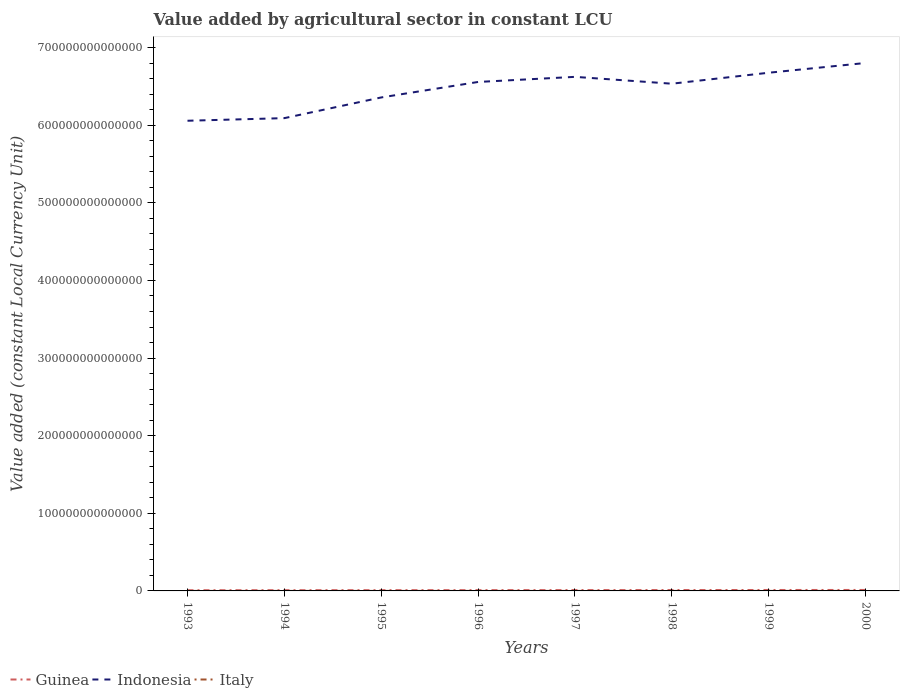Does the line corresponding to Indonesia intersect with the line corresponding to Guinea?
Your response must be concise. No. Is the number of lines equal to the number of legend labels?
Your response must be concise. Yes. Across all years, what is the maximum value added by agricultural sector in Indonesia?
Your answer should be very brief. 6.06e+14. What is the total value added by agricultural sector in Indonesia in the graph?
Provide a short and direct response. -2.65e+13. What is the difference between the highest and the second highest value added by agricultural sector in Guinea?
Your answer should be very brief. 3.37e+11. Is the value added by agricultural sector in Guinea strictly greater than the value added by agricultural sector in Italy over the years?
Make the answer very short. No. What is the difference between two consecutive major ticks on the Y-axis?
Make the answer very short. 1.00e+14. Are the values on the major ticks of Y-axis written in scientific E-notation?
Offer a very short reply. No. Does the graph contain any zero values?
Make the answer very short. No. Does the graph contain grids?
Keep it short and to the point. No. How many legend labels are there?
Provide a short and direct response. 3. How are the legend labels stacked?
Your response must be concise. Horizontal. What is the title of the graph?
Provide a succinct answer. Value added by agricultural sector in constant LCU. Does "Caribbean small states" appear as one of the legend labels in the graph?
Offer a very short reply. No. What is the label or title of the X-axis?
Offer a very short reply. Years. What is the label or title of the Y-axis?
Provide a short and direct response. Value added (constant Local Currency Unit). What is the Value added (constant Local Currency Unit) in Guinea in 1993?
Ensure brevity in your answer.  9.07e+11. What is the Value added (constant Local Currency Unit) in Indonesia in 1993?
Offer a terse response. 6.06e+14. What is the Value added (constant Local Currency Unit) of Italy in 1993?
Provide a short and direct response. 2.63e+1. What is the Value added (constant Local Currency Unit) in Guinea in 1994?
Provide a succinct answer. 9.46e+11. What is the Value added (constant Local Currency Unit) in Indonesia in 1994?
Provide a short and direct response. 6.09e+14. What is the Value added (constant Local Currency Unit) in Italy in 1994?
Your answer should be compact. 2.67e+1. What is the Value added (constant Local Currency Unit) of Guinea in 1995?
Offer a very short reply. 9.75e+11. What is the Value added (constant Local Currency Unit) of Indonesia in 1995?
Your answer should be compact. 6.36e+14. What is the Value added (constant Local Currency Unit) of Italy in 1995?
Make the answer very short. 2.71e+1. What is the Value added (constant Local Currency Unit) in Guinea in 1996?
Keep it short and to the point. 1.02e+12. What is the Value added (constant Local Currency Unit) of Indonesia in 1996?
Your response must be concise. 6.56e+14. What is the Value added (constant Local Currency Unit) in Italy in 1996?
Offer a very short reply. 2.74e+1. What is the Value added (constant Local Currency Unit) of Guinea in 1997?
Offer a terse response. 1.08e+12. What is the Value added (constant Local Currency Unit) of Indonesia in 1997?
Provide a succinct answer. 6.62e+14. What is the Value added (constant Local Currency Unit) in Italy in 1997?
Give a very brief answer. 2.80e+1. What is the Value added (constant Local Currency Unit) of Guinea in 1998?
Keep it short and to the point. 1.13e+12. What is the Value added (constant Local Currency Unit) in Indonesia in 1998?
Keep it short and to the point. 6.54e+14. What is the Value added (constant Local Currency Unit) of Italy in 1998?
Your answer should be compact. 2.88e+1. What is the Value added (constant Local Currency Unit) of Guinea in 1999?
Your answer should be compact. 1.21e+12. What is the Value added (constant Local Currency Unit) in Indonesia in 1999?
Offer a terse response. 6.68e+14. What is the Value added (constant Local Currency Unit) in Italy in 1999?
Give a very brief answer. 3.04e+1. What is the Value added (constant Local Currency Unit) of Guinea in 2000?
Provide a succinct answer. 1.24e+12. What is the Value added (constant Local Currency Unit) in Indonesia in 2000?
Your answer should be very brief. 6.80e+14. What is the Value added (constant Local Currency Unit) of Italy in 2000?
Make the answer very short. 3.00e+1. Across all years, what is the maximum Value added (constant Local Currency Unit) in Guinea?
Keep it short and to the point. 1.24e+12. Across all years, what is the maximum Value added (constant Local Currency Unit) in Indonesia?
Make the answer very short. 6.80e+14. Across all years, what is the maximum Value added (constant Local Currency Unit) of Italy?
Give a very brief answer. 3.04e+1. Across all years, what is the minimum Value added (constant Local Currency Unit) of Guinea?
Your answer should be very brief. 9.07e+11. Across all years, what is the minimum Value added (constant Local Currency Unit) in Indonesia?
Offer a terse response. 6.06e+14. Across all years, what is the minimum Value added (constant Local Currency Unit) of Italy?
Provide a succinct answer. 2.63e+1. What is the total Value added (constant Local Currency Unit) of Guinea in the graph?
Make the answer very short. 8.51e+12. What is the total Value added (constant Local Currency Unit) in Indonesia in the graph?
Provide a short and direct response. 5.17e+15. What is the total Value added (constant Local Currency Unit) of Italy in the graph?
Offer a very short reply. 2.25e+11. What is the difference between the Value added (constant Local Currency Unit) of Guinea in 1993 and that in 1994?
Your answer should be very brief. -3.95e+1. What is the difference between the Value added (constant Local Currency Unit) in Indonesia in 1993 and that in 1994?
Make the answer very short. -3.37e+12. What is the difference between the Value added (constant Local Currency Unit) in Italy in 1993 and that in 1994?
Offer a terse response. -3.83e+08. What is the difference between the Value added (constant Local Currency Unit) of Guinea in 1993 and that in 1995?
Ensure brevity in your answer.  -6.84e+1. What is the difference between the Value added (constant Local Currency Unit) of Indonesia in 1993 and that in 1995?
Provide a succinct answer. -3.00e+13. What is the difference between the Value added (constant Local Currency Unit) of Italy in 1993 and that in 1995?
Give a very brief answer. -8.41e+08. What is the difference between the Value added (constant Local Currency Unit) in Guinea in 1993 and that in 1996?
Ensure brevity in your answer.  -1.11e+11. What is the difference between the Value added (constant Local Currency Unit) in Indonesia in 1993 and that in 1996?
Ensure brevity in your answer.  -5.00e+13. What is the difference between the Value added (constant Local Currency Unit) of Italy in 1993 and that in 1996?
Your answer should be compact. -1.15e+09. What is the difference between the Value added (constant Local Currency Unit) in Guinea in 1993 and that in 1997?
Provide a short and direct response. -1.76e+11. What is the difference between the Value added (constant Local Currency Unit) in Indonesia in 1993 and that in 1997?
Provide a short and direct response. -5.66e+13. What is the difference between the Value added (constant Local Currency Unit) of Italy in 1993 and that in 1997?
Provide a short and direct response. -1.75e+09. What is the difference between the Value added (constant Local Currency Unit) in Guinea in 1993 and that in 1998?
Your response must be concise. -2.27e+11. What is the difference between the Value added (constant Local Currency Unit) in Indonesia in 1993 and that in 1998?
Offer a terse response. -4.77e+13. What is the difference between the Value added (constant Local Currency Unit) in Italy in 1993 and that in 1998?
Your answer should be very brief. -2.50e+09. What is the difference between the Value added (constant Local Currency Unit) in Guinea in 1993 and that in 1999?
Make the answer very short. -3.01e+11. What is the difference between the Value added (constant Local Currency Unit) of Indonesia in 1993 and that in 1999?
Your response must be concise. -6.19e+13. What is the difference between the Value added (constant Local Currency Unit) of Italy in 1993 and that in 1999?
Provide a succinct answer. -4.15e+09. What is the difference between the Value added (constant Local Currency Unit) of Guinea in 1993 and that in 2000?
Your response must be concise. -3.37e+11. What is the difference between the Value added (constant Local Currency Unit) of Indonesia in 1993 and that in 2000?
Offer a very short reply. -7.44e+13. What is the difference between the Value added (constant Local Currency Unit) of Italy in 1993 and that in 2000?
Your answer should be compact. -3.75e+09. What is the difference between the Value added (constant Local Currency Unit) in Guinea in 1994 and that in 1995?
Provide a succinct answer. -2.89e+1. What is the difference between the Value added (constant Local Currency Unit) of Indonesia in 1994 and that in 1995?
Keep it short and to the point. -2.67e+13. What is the difference between the Value added (constant Local Currency Unit) in Italy in 1994 and that in 1995?
Make the answer very short. -4.58e+08. What is the difference between the Value added (constant Local Currency Unit) of Guinea in 1994 and that in 1996?
Your answer should be very brief. -7.10e+1. What is the difference between the Value added (constant Local Currency Unit) in Indonesia in 1994 and that in 1996?
Provide a short and direct response. -4.66e+13. What is the difference between the Value added (constant Local Currency Unit) of Italy in 1994 and that in 1996?
Offer a very short reply. -7.68e+08. What is the difference between the Value added (constant Local Currency Unit) in Guinea in 1994 and that in 1997?
Offer a very short reply. -1.37e+11. What is the difference between the Value added (constant Local Currency Unit) of Indonesia in 1994 and that in 1997?
Make the answer very short. -5.32e+13. What is the difference between the Value added (constant Local Currency Unit) in Italy in 1994 and that in 1997?
Offer a terse response. -1.37e+09. What is the difference between the Value added (constant Local Currency Unit) of Guinea in 1994 and that in 1998?
Provide a short and direct response. -1.87e+11. What is the difference between the Value added (constant Local Currency Unit) of Indonesia in 1994 and that in 1998?
Provide a short and direct response. -4.44e+13. What is the difference between the Value added (constant Local Currency Unit) of Italy in 1994 and that in 1998?
Provide a succinct answer. -2.11e+09. What is the difference between the Value added (constant Local Currency Unit) in Guinea in 1994 and that in 1999?
Your response must be concise. -2.62e+11. What is the difference between the Value added (constant Local Currency Unit) of Indonesia in 1994 and that in 1999?
Ensure brevity in your answer.  -5.85e+13. What is the difference between the Value added (constant Local Currency Unit) in Italy in 1994 and that in 1999?
Keep it short and to the point. -3.76e+09. What is the difference between the Value added (constant Local Currency Unit) of Guinea in 1994 and that in 2000?
Provide a succinct answer. -2.98e+11. What is the difference between the Value added (constant Local Currency Unit) of Indonesia in 1994 and that in 2000?
Keep it short and to the point. -7.11e+13. What is the difference between the Value added (constant Local Currency Unit) in Italy in 1994 and that in 2000?
Give a very brief answer. -3.36e+09. What is the difference between the Value added (constant Local Currency Unit) of Guinea in 1995 and that in 1996?
Keep it short and to the point. -4.21e+1. What is the difference between the Value added (constant Local Currency Unit) in Indonesia in 1995 and that in 1996?
Offer a terse response. -2.00e+13. What is the difference between the Value added (constant Local Currency Unit) of Italy in 1995 and that in 1996?
Offer a very short reply. -3.10e+08. What is the difference between the Value added (constant Local Currency Unit) of Guinea in 1995 and that in 1997?
Your answer should be very brief. -1.08e+11. What is the difference between the Value added (constant Local Currency Unit) of Indonesia in 1995 and that in 1997?
Ensure brevity in your answer.  -2.65e+13. What is the difference between the Value added (constant Local Currency Unit) in Italy in 1995 and that in 1997?
Ensure brevity in your answer.  -9.11e+08. What is the difference between the Value added (constant Local Currency Unit) in Guinea in 1995 and that in 1998?
Your answer should be very brief. -1.58e+11. What is the difference between the Value added (constant Local Currency Unit) of Indonesia in 1995 and that in 1998?
Provide a succinct answer. -1.77e+13. What is the difference between the Value added (constant Local Currency Unit) of Italy in 1995 and that in 1998?
Your response must be concise. -1.66e+09. What is the difference between the Value added (constant Local Currency Unit) in Guinea in 1995 and that in 1999?
Give a very brief answer. -2.33e+11. What is the difference between the Value added (constant Local Currency Unit) in Indonesia in 1995 and that in 1999?
Provide a short and direct response. -3.19e+13. What is the difference between the Value added (constant Local Currency Unit) of Italy in 1995 and that in 1999?
Provide a succinct answer. -3.31e+09. What is the difference between the Value added (constant Local Currency Unit) in Guinea in 1995 and that in 2000?
Your answer should be compact. -2.69e+11. What is the difference between the Value added (constant Local Currency Unit) in Indonesia in 1995 and that in 2000?
Your answer should be very brief. -4.44e+13. What is the difference between the Value added (constant Local Currency Unit) of Italy in 1995 and that in 2000?
Offer a terse response. -2.91e+09. What is the difference between the Value added (constant Local Currency Unit) of Guinea in 1996 and that in 1997?
Offer a terse response. -6.59e+1. What is the difference between the Value added (constant Local Currency Unit) in Indonesia in 1996 and that in 1997?
Give a very brief answer. -6.58e+12. What is the difference between the Value added (constant Local Currency Unit) of Italy in 1996 and that in 1997?
Offer a terse response. -6.01e+08. What is the difference between the Value added (constant Local Currency Unit) in Guinea in 1996 and that in 1998?
Give a very brief answer. -1.16e+11. What is the difference between the Value added (constant Local Currency Unit) in Indonesia in 1996 and that in 1998?
Keep it short and to the point. 2.24e+12. What is the difference between the Value added (constant Local Currency Unit) of Italy in 1996 and that in 1998?
Provide a succinct answer. -1.35e+09. What is the difference between the Value added (constant Local Currency Unit) in Guinea in 1996 and that in 1999?
Offer a very short reply. -1.91e+11. What is the difference between the Value added (constant Local Currency Unit) in Indonesia in 1996 and that in 1999?
Give a very brief answer. -1.19e+13. What is the difference between the Value added (constant Local Currency Unit) of Italy in 1996 and that in 1999?
Offer a terse response. -3.00e+09. What is the difference between the Value added (constant Local Currency Unit) in Guinea in 1996 and that in 2000?
Provide a short and direct response. -2.27e+11. What is the difference between the Value added (constant Local Currency Unit) in Indonesia in 1996 and that in 2000?
Provide a short and direct response. -2.45e+13. What is the difference between the Value added (constant Local Currency Unit) of Italy in 1996 and that in 2000?
Offer a terse response. -2.60e+09. What is the difference between the Value added (constant Local Currency Unit) in Guinea in 1997 and that in 1998?
Ensure brevity in your answer.  -5.02e+1. What is the difference between the Value added (constant Local Currency Unit) of Indonesia in 1997 and that in 1998?
Make the answer very short. 8.82e+12. What is the difference between the Value added (constant Local Currency Unit) in Italy in 1997 and that in 1998?
Offer a very short reply. -7.46e+08. What is the difference between the Value added (constant Local Currency Unit) in Guinea in 1997 and that in 1999?
Your response must be concise. -1.25e+11. What is the difference between the Value added (constant Local Currency Unit) of Indonesia in 1997 and that in 1999?
Your answer should be compact. -5.32e+12. What is the difference between the Value added (constant Local Currency Unit) of Italy in 1997 and that in 1999?
Your response must be concise. -2.40e+09. What is the difference between the Value added (constant Local Currency Unit) of Guinea in 1997 and that in 2000?
Provide a short and direct response. -1.61e+11. What is the difference between the Value added (constant Local Currency Unit) of Indonesia in 1997 and that in 2000?
Keep it short and to the point. -1.79e+13. What is the difference between the Value added (constant Local Currency Unit) in Italy in 1997 and that in 2000?
Provide a short and direct response. -2.00e+09. What is the difference between the Value added (constant Local Currency Unit) in Guinea in 1998 and that in 1999?
Keep it short and to the point. -7.49e+1. What is the difference between the Value added (constant Local Currency Unit) of Indonesia in 1998 and that in 1999?
Your answer should be very brief. -1.41e+13. What is the difference between the Value added (constant Local Currency Unit) in Italy in 1998 and that in 1999?
Keep it short and to the point. -1.65e+09. What is the difference between the Value added (constant Local Currency Unit) of Guinea in 1998 and that in 2000?
Provide a succinct answer. -1.10e+11. What is the difference between the Value added (constant Local Currency Unit) of Indonesia in 1998 and that in 2000?
Give a very brief answer. -2.67e+13. What is the difference between the Value added (constant Local Currency Unit) of Italy in 1998 and that in 2000?
Offer a very short reply. -1.25e+09. What is the difference between the Value added (constant Local Currency Unit) in Guinea in 1999 and that in 2000?
Your response must be concise. -3.56e+1. What is the difference between the Value added (constant Local Currency Unit) of Indonesia in 1999 and that in 2000?
Your answer should be very brief. -1.26e+13. What is the difference between the Value added (constant Local Currency Unit) in Italy in 1999 and that in 2000?
Your answer should be very brief. 4.00e+08. What is the difference between the Value added (constant Local Currency Unit) in Guinea in 1993 and the Value added (constant Local Currency Unit) in Indonesia in 1994?
Offer a terse response. -6.08e+14. What is the difference between the Value added (constant Local Currency Unit) of Guinea in 1993 and the Value added (constant Local Currency Unit) of Italy in 1994?
Provide a succinct answer. 8.80e+11. What is the difference between the Value added (constant Local Currency Unit) of Indonesia in 1993 and the Value added (constant Local Currency Unit) of Italy in 1994?
Your answer should be very brief. 6.06e+14. What is the difference between the Value added (constant Local Currency Unit) in Guinea in 1993 and the Value added (constant Local Currency Unit) in Indonesia in 1995?
Provide a succinct answer. -6.35e+14. What is the difference between the Value added (constant Local Currency Unit) of Guinea in 1993 and the Value added (constant Local Currency Unit) of Italy in 1995?
Your answer should be compact. 8.80e+11. What is the difference between the Value added (constant Local Currency Unit) in Indonesia in 1993 and the Value added (constant Local Currency Unit) in Italy in 1995?
Keep it short and to the point. 6.06e+14. What is the difference between the Value added (constant Local Currency Unit) in Guinea in 1993 and the Value added (constant Local Currency Unit) in Indonesia in 1996?
Give a very brief answer. -6.55e+14. What is the difference between the Value added (constant Local Currency Unit) in Guinea in 1993 and the Value added (constant Local Currency Unit) in Italy in 1996?
Provide a succinct answer. 8.79e+11. What is the difference between the Value added (constant Local Currency Unit) in Indonesia in 1993 and the Value added (constant Local Currency Unit) in Italy in 1996?
Your response must be concise. 6.06e+14. What is the difference between the Value added (constant Local Currency Unit) of Guinea in 1993 and the Value added (constant Local Currency Unit) of Indonesia in 1997?
Offer a terse response. -6.61e+14. What is the difference between the Value added (constant Local Currency Unit) in Guinea in 1993 and the Value added (constant Local Currency Unit) in Italy in 1997?
Your response must be concise. 8.79e+11. What is the difference between the Value added (constant Local Currency Unit) of Indonesia in 1993 and the Value added (constant Local Currency Unit) of Italy in 1997?
Keep it short and to the point. 6.06e+14. What is the difference between the Value added (constant Local Currency Unit) in Guinea in 1993 and the Value added (constant Local Currency Unit) in Indonesia in 1998?
Offer a terse response. -6.53e+14. What is the difference between the Value added (constant Local Currency Unit) of Guinea in 1993 and the Value added (constant Local Currency Unit) of Italy in 1998?
Provide a succinct answer. 8.78e+11. What is the difference between the Value added (constant Local Currency Unit) in Indonesia in 1993 and the Value added (constant Local Currency Unit) in Italy in 1998?
Your answer should be very brief. 6.06e+14. What is the difference between the Value added (constant Local Currency Unit) in Guinea in 1993 and the Value added (constant Local Currency Unit) in Indonesia in 1999?
Keep it short and to the point. -6.67e+14. What is the difference between the Value added (constant Local Currency Unit) in Guinea in 1993 and the Value added (constant Local Currency Unit) in Italy in 1999?
Your answer should be very brief. 8.76e+11. What is the difference between the Value added (constant Local Currency Unit) in Indonesia in 1993 and the Value added (constant Local Currency Unit) in Italy in 1999?
Ensure brevity in your answer.  6.06e+14. What is the difference between the Value added (constant Local Currency Unit) of Guinea in 1993 and the Value added (constant Local Currency Unit) of Indonesia in 2000?
Make the answer very short. -6.79e+14. What is the difference between the Value added (constant Local Currency Unit) in Guinea in 1993 and the Value added (constant Local Currency Unit) in Italy in 2000?
Provide a succinct answer. 8.77e+11. What is the difference between the Value added (constant Local Currency Unit) of Indonesia in 1993 and the Value added (constant Local Currency Unit) of Italy in 2000?
Ensure brevity in your answer.  6.06e+14. What is the difference between the Value added (constant Local Currency Unit) of Guinea in 1994 and the Value added (constant Local Currency Unit) of Indonesia in 1995?
Your answer should be compact. -6.35e+14. What is the difference between the Value added (constant Local Currency Unit) in Guinea in 1994 and the Value added (constant Local Currency Unit) in Italy in 1995?
Keep it short and to the point. 9.19e+11. What is the difference between the Value added (constant Local Currency Unit) in Indonesia in 1994 and the Value added (constant Local Currency Unit) in Italy in 1995?
Ensure brevity in your answer.  6.09e+14. What is the difference between the Value added (constant Local Currency Unit) of Guinea in 1994 and the Value added (constant Local Currency Unit) of Indonesia in 1996?
Make the answer very short. -6.55e+14. What is the difference between the Value added (constant Local Currency Unit) in Guinea in 1994 and the Value added (constant Local Currency Unit) in Italy in 1996?
Keep it short and to the point. 9.19e+11. What is the difference between the Value added (constant Local Currency Unit) in Indonesia in 1994 and the Value added (constant Local Currency Unit) in Italy in 1996?
Ensure brevity in your answer.  6.09e+14. What is the difference between the Value added (constant Local Currency Unit) in Guinea in 1994 and the Value added (constant Local Currency Unit) in Indonesia in 1997?
Your answer should be very brief. -6.61e+14. What is the difference between the Value added (constant Local Currency Unit) in Guinea in 1994 and the Value added (constant Local Currency Unit) in Italy in 1997?
Offer a very short reply. 9.18e+11. What is the difference between the Value added (constant Local Currency Unit) in Indonesia in 1994 and the Value added (constant Local Currency Unit) in Italy in 1997?
Your answer should be very brief. 6.09e+14. What is the difference between the Value added (constant Local Currency Unit) of Guinea in 1994 and the Value added (constant Local Currency Unit) of Indonesia in 1998?
Provide a short and direct response. -6.53e+14. What is the difference between the Value added (constant Local Currency Unit) in Guinea in 1994 and the Value added (constant Local Currency Unit) in Italy in 1998?
Your answer should be compact. 9.18e+11. What is the difference between the Value added (constant Local Currency Unit) in Indonesia in 1994 and the Value added (constant Local Currency Unit) in Italy in 1998?
Ensure brevity in your answer.  6.09e+14. What is the difference between the Value added (constant Local Currency Unit) in Guinea in 1994 and the Value added (constant Local Currency Unit) in Indonesia in 1999?
Your answer should be compact. -6.67e+14. What is the difference between the Value added (constant Local Currency Unit) in Guinea in 1994 and the Value added (constant Local Currency Unit) in Italy in 1999?
Your answer should be very brief. 9.16e+11. What is the difference between the Value added (constant Local Currency Unit) of Indonesia in 1994 and the Value added (constant Local Currency Unit) of Italy in 1999?
Give a very brief answer. 6.09e+14. What is the difference between the Value added (constant Local Currency Unit) of Guinea in 1994 and the Value added (constant Local Currency Unit) of Indonesia in 2000?
Keep it short and to the point. -6.79e+14. What is the difference between the Value added (constant Local Currency Unit) of Guinea in 1994 and the Value added (constant Local Currency Unit) of Italy in 2000?
Provide a short and direct response. 9.16e+11. What is the difference between the Value added (constant Local Currency Unit) in Indonesia in 1994 and the Value added (constant Local Currency Unit) in Italy in 2000?
Your response must be concise. 6.09e+14. What is the difference between the Value added (constant Local Currency Unit) of Guinea in 1995 and the Value added (constant Local Currency Unit) of Indonesia in 1996?
Offer a terse response. -6.55e+14. What is the difference between the Value added (constant Local Currency Unit) in Guinea in 1995 and the Value added (constant Local Currency Unit) in Italy in 1996?
Keep it short and to the point. 9.48e+11. What is the difference between the Value added (constant Local Currency Unit) in Indonesia in 1995 and the Value added (constant Local Currency Unit) in Italy in 1996?
Provide a succinct answer. 6.36e+14. What is the difference between the Value added (constant Local Currency Unit) in Guinea in 1995 and the Value added (constant Local Currency Unit) in Indonesia in 1997?
Your answer should be very brief. -6.61e+14. What is the difference between the Value added (constant Local Currency Unit) of Guinea in 1995 and the Value added (constant Local Currency Unit) of Italy in 1997?
Your answer should be very brief. 9.47e+11. What is the difference between the Value added (constant Local Currency Unit) of Indonesia in 1995 and the Value added (constant Local Currency Unit) of Italy in 1997?
Keep it short and to the point. 6.36e+14. What is the difference between the Value added (constant Local Currency Unit) in Guinea in 1995 and the Value added (constant Local Currency Unit) in Indonesia in 1998?
Offer a terse response. -6.53e+14. What is the difference between the Value added (constant Local Currency Unit) in Guinea in 1995 and the Value added (constant Local Currency Unit) in Italy in 1998?
Keep it short and to the point. 9.47e+11. What is the difference between the Value added (constant Local Currency Unit) in Indonesia in 1995 and the Value added (constant Local Currency Unit) in Italy in 1998?
Provide a short and direct response. 6.36e+14. What is the difference between the Value added (constant Local Currency Unit) in Guinea in 1995 and the Value added (constant Local Currency Unit) in Indonesia in 1999?
Provide a short and direct response. -6.67e+14. What is the difference between the Value added (constant Local Currency Unit) of Guinea in 1995 and the Value added (constant Local Currency Unit) of Italy in 1999?
Keep it short and to the point. 9.45e+11. What is the difference between the Value added (constant Local Currency Unit) in Indonesia in 1995 and the Value added (constant Local Currency Unit) in Italy in 1999?
Your answer should be compact. 6.36e+14. What is the difference between the Value added (constant Local Currency Unit) in Guinea in 1995 and the Value added (constant Local Currency Unit) in Indonesia in 2000?
Your answer should be compact. -6.79e+14. What is the difference between the Value added (constant Local Currency Unit) of Guinea in 1995 and the Value added (constant Local Currency Unit) of Italy in 2000?
Offer a terse response. 9.45e+11. What is the difference between the Value added (constant Local Currency Unit) of Indonesia in 1995 and the Value added (constant Local Currency Unit) of Italy in 2000?
Ensure brevity in your answer.  6.36e+14. What is the difference between the Value added (constant Local Currency Unit) of Guinea in 1996 and the Value added (constant Local Currency Unit) of Indonesia in 1997?
Offer a terse response. -6.61e+14. What is the difference between the Value added (constant Local Currency Unit) in Guinea in 1996 and the Value added (constant Local Currency Unit) in Italy in 1997?
Your response must be concise. 9.89e+11. What is the difference between the Value added (constant Local Currency Unit) of Indonesia in 1996 and the Value added (constant Local Currency Unit) of Italy in 1997?
Offer a terse response. 6.56e+14. What is the difference between the Value added (constant Local Currency Unit) in Guinea in 1996 and the Value added (constant Local Currency Unit) in Indonesia in 1998?
Provide a succinct answer. -6.53e+14. What is the difference between the Value added (constant Local Currency Unit) in Guinea in 1996 and the Value added (constant Local Currency Unit) in Italy in 1998?
Provide a short and direct response. 9.89e+11. What is the difference between the Value added (constant Local Currency Unit) in Indonesia in 1996 and the Value added (constant Local Currency Unit) in Italy in 1998?
Keep it short and to the point. 6.56e+14. What is the difference between the Value added (constant Local Currency Unit) of Guinea in 1996 and the Value added (constant Local Currency Unit) of Indonesia in 1999?
Ensure brevity in your answer.  -6.67e+14. What is the difference between the Value added (constant Local Currency Unit) in Guinea in 1996 and the Value added (constant Local Currency Unit) in Italy in 1999?
Provide a succinct answer. 9.87e+11. What is the difference between the Value added (constant Local Currency Unit) of Indonesia in 1996 and the Value added (constant Local Currency Unit) of Italy in 1999?
Make the answer very short. 6.56e+14. What is the difference between the Value added (constant Local Currency Unit) of Guinea in 1996 and the Value added (constant Local Currency Unit) of Indonesia in 2000?
Your answer should be compact. -6.79e+14. What is the difference between the Value added (constant Local Currency Unit) of Guinea in 1996 and the Value added (constant Local Currency Unit) of Italy in 2000?
Ensure brevity in your answer.  9.87e+11. What is the difference between the Value added (constant Local Currency Unit) in Indonesia in 1996 and the Value added (constant Local Currency Unit) in Italy in 2000?
Offer a terse response. 6.56e+14. What is the difference between the Value added (constant Local Currency Unit) in Guinea in 1997 and the Value added (constant Local Currency Unit) in Indonesia in 1998?
Make the answer very short. -6.52e+14. What is the difference between the Value added (constant Local Currency Unit) in Guinea in 1997 and the Value added (constant Local Currency Unit) in Italy in 1998?
Keep it short and to the point. 1.05e+12. What is the difference between the Value added (constant Local Currency Unit) of Indonesia in 1997 and the Value added (constant Local Currency Unit) of Italy in 1998?
Offer a very short reply. 6.62e+14. What is the difference between the Value added (constant Local Currency Unit) of Guinea in 1997 and the Value added (constant Local Currency Unit) of Indonesia in 1999?
Give a very brief answer. -6.67e+14. What is the difference between the Value added (constant Local Currency Unit) in Guinea in 1997 and the Value added (constant Local Currency Unit) in Italy in 1999?
Ensure brevity in your answer.  1.05e+12. What is the difference between the Value added (constant Local Currency Unit) of Indonesia in 1997 and the Value added (constant Local Currency Unit) of Italy in 1999?
Ensure brevity in your answer.  6.62e+14. What is the difference between the Value added (constant Local Currency Unit) in Guinea in 1997 and the Value added (constant Local Currency Unit) in Indonesia in 2000?
Make the answer very short. -6.79e+14. What is the difference between the Value added (constant Local Currency Unit) of Guinea in 1997 and the Value added (constant Local Currency Unit) of Italy in 2000?
Your response must be concise. 1.05e+12. What is the difference between the Value added (constant Local Currency Unit) of Indonesia in 1997 and the Value added (constant Local Currency Unit) of Italy in 2000?
Your answer should be very brief. 6.62e+14. What is the difference between the Value added (constant Local Currency Unit) in Guinea in 1998 and the Value added (constant Local Currency Unit) in Indonesia in 1999?
Your response must be concise. -6.67e+14. What is the difference between the Value added (constant Local Currency Unit) in Guinea in 1998 and the Value added (constant Local Currency Unit) in Italy in 1999?
Ensure brevity in your answer.  1.10e+12. What is the difference between the Value added (constant Local Currency Unit) of Indonesia in 1998 and the Value added (constant Local Currency Unit) of Italy in 1999?
Your response must be concise. 6.53e+14. What is the difference between the Value added (constant Local Currency Unit) of Guinea in 1998 and the Value added (constant Local Currency Unit) of Indonesia in 2000?
Ensure brevity in your answer.  -6.79e+14. What is the difference between the Value added (constant Local Currency Unit) in Guinea in 1998 and the Value added (constant Local Currency Unit) in Italy in 2000?
Your response must be concise. 1.10e+12. What is the difference between the Value added (constant Local Currency Unit) of Indonesia in 1998 and the Value added (constant Local Currency Unit) of Italy in 2000?
Ensure brevity in your answer.  6.53e+14. What is the difference between the Value added (constant Local Currency Unit) in Guinea in 1999 and the Value added (constant Local Currency Unit) in Indonesia in 2000?
Your answer should be very brief. -6.79e+14. What is the difference between the Value added (constant Local Currency Unit) of Guinea in 1999 and the Value added (constant Local Currency Unit) of Italy in 2000?
Your answer should be compact. 1.18e+12. What is the difference between the Value added (constant Local Currency Unit) of Indonesia in 1999 and the Value added (constant Local Currency Unit) of Italy in 2000?
Your answer should be compact. 6.68e+14. What is the average Value added (constant Local Currency Unit) in Guinea per year?
Make the answer very short. 1.06e+12. What is the average Value added (constant Local Currency Unit) of Indonesia per year?
Your answer should be compact. 6.46e+14. What is the average Value added (constant Local Currency Unit) in Italy per year?
Offer a very short reply. 2.81e+1. In the year 1993, what is the difference between the Value added (constant Local Currency Unit) of Guinea and Value added (constant Local Currency Unit) of Indonesia?
Your response must be concise. -6.05e+14. In the year 1993, what is the difference between the Value added (constant Local Currency Unit) in Guinea and Value added (constant Local Currency Unit) in Italy?
Provide a short and direct response. 8.81e+11. In the year 1993, what is the difference between the Value added (constant Local Currency Unit) in Indonesia and Value added (constant Local Currency Unit) in Italy?
Offer a very short reply. 6.06e+14. In the year 1994, what is the difference between the Value added (constant Local Currency Unit) in Guinea and Value added (constant Local Currency Unit) in Indonesia?
Offer a very short reply. -6.08e+14. In the year 1994, what is the difference between the Value added (constant Local Currency Unit) of Guinea and Value added (constant Local Currency Unit) of Italy?
Give a very brief answer. 9.20e+11. In the year 1994, what is the difference between the Value added (constant Local Currency Unit) of Indonesia and Value added (constant Local Currency Unit) of Italy?
Offer a terse response. 6.09e+14. In the year 1995, what is the difference between the Value added (constant Local Currency Unit) in Guinea and Value added (constant Local Currency Unit) in Indonesia?
Give a very brief answer. -6.35e+14. In the year 1995, what is the difference between the Value added (constant Local Currency Unit) in Guinea and Value added (constant Local Currency Unit) in Italy?
Your answer should be very brief. 9.48e+11. In the year 1995, what is the difference between the Value added (constant Local Currency Unit) of Indonesia and Value added (constant Local Currency Unit) of Italy?
Offer a terse response. 6.36e+14. In the year 1996, what is the difference between the Value added (constant Local Currency Unit) of Guinea and Value added (constant Local Currency Unit) of Indonesia?
Ensure brevity in your answer.  -6.55e+14. In the year 1996, what is the difference between the Value added (constant Local Currency Unit) in Guinea and Value added (constant Local Currency Unit) in Italy?
Keep it short and to the point. 9.90e+11. In the year 1996, what is the difference between the Value added (constant Local Currency Unit) in Indonesia and Value added (constant Local Currency Unit) in Italy?
Ensure brevity in your answer.  6.56e+14. In the year 1997, what is the difference between the Value added (constant Local Currency Unit) in Guinea and Value added (constant Local Currency Unit) in Indonesia?
Keep it short and to the point. -6.61e+14. In the year 1997, what is the difference between the Value added (constant Local Currency Unit) in Guinea and Value added (constant Local Currency Unit) in Italy?
Your answer should be very brief. 1.06e+12. In the year 1997, what is the difference between the Value added (constant Local Currency Unit) in Indonesia and Value added (constant Local Currency Unit) in Italy?
Ensure brevity in your answer.  6.62e+14. In the year 1998, what is the difference between the Value added (constant Local Currency Unit) in Guinea and Value added (constant Local Currency Unit) in Indonesia?
Your response must be concise. -6.52e+14. In the year 1998, what is the difference between the Value added (constant Local Currency Unit) in Guinea and Value added (constant Local Currency Unit) in Italy?
Give a very brief answer. 1.10e+12. In the year 1998, what is the difference between the Value added (constant Local Currency Unit) of Indonesia and Value added (constant Local Currency Unit) of Italy?
Give a very brief answer. 6.53e+14. In the year 1999, what is the difference between the Value added (constant Local Currency Unit) of Guinea and Value added (constant Local Currency Unit) of Indonesia?
Make the answer very short. -6.66e+14. In the year 1999, what is the difference between the Value added (constant Local Currency Unit) in Guinea and Value added (constant Local Currency Unit) in Italy?
Offer a terse response. 1.18e+12. In the year 1999, what is the difference between the Value added (constant Local Currency Unit) of Indonesia and Value added (constant Local Currency Unit) of Italy?
Your answer should be compact. 6.68e+14. In the year 2000, what is the difference between the Value added (constant Local Currency Unit) of Guinea and Value added (constant Local Currency Unit) of Indonesia?
Provide a short and direct response. -6.79e+14. In the year 2000, what is the difference between the Value added (constant Local Currency Unit) in Guinea and Value added (constant Local Currency Unit) in Italy?
Your answer should be very brief. 1.21e+12. In the year 2000, what is the difference between the Value added (constant Local Currency Unit) in Indonesia and Value added (constant Local Currency Unit) in Italy?
Provide a succinct answer. 6.80e+14. What is the ratio of the Value added (constant Local Currency Unit) in Italy in 1993 to that in 1994?
Ensure brevity in your answer.  0.99. What is the ratio of the Value added (constant Local Currency Unit) in Guinea in 1993 to that in 1995?
Your answer should be compact. 0.93. What is the ratio of the Value added (constant Local Currency Unit) in Indonesia in 1993 to that in 1995?
Your response must be concise. 0.95. What is the ratio of the Value added (constant Local Currency Unit) in Italy in 1993 to that in 1995?
Offer a very short reply. 0.97. What is the ratio of the Value added (constant Local Currency Unit) in Guinea in 1993 to that in 1996?
Offer a terse response. 0.89. What is the ratio of the Value added (constant Local Currency Unit) of Indonesia in 1993 to that in 1996?
Your answer should be compact. 0.92. What is the ratio of the Value added (constant Local Currency Unit) of Italy in 1993 to that in 1996?
Provide a short and direct response. 0.96. What is the ratio of the Value added (constant Local Currency Unit) in Guinea in 1993 to that in 1997?
Make the answer very short. 0.84. What is the ratio of the Value added (constant Local Currency Unit) in Indonesia in 1993 to that in 1997?
Make the answer very short. 0.91. What is the ratio of the Value added (constant Local Currency Unit) in Italy in 1993 to that in 1997?
Ensure brevity in your answer.  0.94. What is the ratio of the Value added (constant Local Currency Unit) of Guinea in 1993 to that in 1998?
Your response must be concise. 0.8. What is the ratio of the Value added (constant Local Currency Unit) of Indonesia in 1993 to that in 1998?
Your answer should be compact. 0.93. What is the ratio of the Value added (constant Local Currency Unit) of Italy in 1993 to that in 1998?
Your answer should be compact. 0.91. What is the ratio of the Value added (constant Local Currency Unit) in Guinea in 1993 to that in 1999?
Provide a short and direct response. 0.75. What is the ratio of the Value added (constant Local Currency Unit) of Indonesia in 1993 to that in 1999?
Make the answer very short. 0.91. What is the ratio of the Value added (constant Local Currency Unit) of Italy in 1993 to that in 1999?
Offer a very short reply. 0.86. What is the ratio of the Value added (constant Local Currency Unit) in Guinea in 1993 to that in 2000?
Offer a very short reply. 0.73. What is the ratio of the Value added (constant Local Currency Unit) in Indonesia in 1993 to that in 2000?
Offer a very short reply. 0.89. What is the ratio of the Value added (constant Local Currency Unit) of Italy in 1993 to that in 2000?
Offer a very short reply. 0.88. What is the ratio of the Value added (constant Local Currency Unit) of Guinea in 1994 to that in 1995?
Your answer should be very brief. 0.97. What is the ratio of the Value added (constant Local Currency Unit) of Indonesia in 1994 to that in 1995?
Provide a succinct answer. 0.96. What is the ratio of the Value added (constant Local Currency Unit) in Italy in 1994 to that in 1995?
Your answer should be very brief. 0.98. What is the ratio of the Value added (constant Local Currency Unit) of Guinea in 1994 to that in 1996?
Offer a very short reply. 0.93. What is the ratio of the Value added (constant Local Currency Unit) of Indonesia in 1994 to that in 1996?
Your answer should be compact. 0.93. What is the ratio of the Value added (constant Local Currency Unit) of Italy in 1994 to that in 1996?
Ensure brevity in your answer.  0.97. What is the ratio of the Value added (constant Local Currency Unit) in Guinea in 1994 to that in 1997?
Provide a short and direct response. 0.87. What is the ratio of the Value added (constant Local Currency Unit) of Indonesia in 1994 to that in 1997?
Your response must be concise. 0.92. What is the ratio of the Value added (constant Local Currency Unit) of Italy in 1994 to that in 1997?
Offer a very short reply. 0.95. What is the ratio of the Value added (constant Local Currency Unit) of Guinea in 1994 to that in 1998?
Your response must be concise. 0.83. What is the ratio of the Value added (constant Local Currency Unit) of Indonesia in 1994 to that in 1998?
Your response must be concise. 0.93. What is the ratio of the Value added (constant Local Currency Unit) of Italy in 1994 to that in 1998?
Give a very brief answer. 0.93. What is the ratio of the Value added (constant Local Currency Unit) in Guinea in 1994 to that in 1999?
Give a very brief answer. 0.78. What is the ratio of the Value added (constant Local Currency Unit) of Indonesia in 1994 to that in 1999?
Your answer should be very brief. 0.91. What is the ratio of the Value added (constant Local Currency Unit) in Italy in 1994 to that in 1999?
Your answer should be very brief. 0.88. What is the ratio of the Value added (constant Local Currency Unit) of Guinea in 1994 to that in 2000?
Provide a short and direct response. 0.76. What is the ratio of the Value added (constant Local Currency Unit) in Indonesia in 1994 to that in 2000?
Your response must be concise. 0.9. What is the ratio of the Value added (constant Local Currency Unit) in Italy in 1994 to that in 2000?
Give a very brief answer. 0.89. What is the ratio of the Value added (constant Local Currency Unit) in Guinea in 1995 to that in 1996?
Offer a terse response. 0.96. What is the ratio of the Value added (constant Local Currency Unit) of Indonesia in 1995 to that in 1996?
Provide a short and direct response. 0.97. What is the ratio of the Value added (constant Local Currency Unit) in Italy in 1995 to that in 1996?
Your answer should be compact. 0.99. What is the ratio of the Value added (constant Local Currency Unit) of Guinea in 1995 to that in 1997?
Make the answer very short. 0.9. What is the ratio of the Value added (constant Local Currency Unit) in Indonesia in 1995 to that in 1997?
Your answer should be very brief. 0.96. What is the ratio of the Value added (constant Local Currency Unit) in Italy in 1995 to that in 1997?
Provide a short and direct response. 0.97. What is the ratio of the Value added (constant Local Currency Unit) in Guinea in 1995 to that in 1998?
Offer a very short reply. 0.86. What is the ratio of the Value added (constant Local Currency Unit) in Indonesia in 1995 to that in 1998?
Keep it short and to the point. 0.97. What is the ratio of the Value added (constant Local Currency Unit) in Italy in 1995 to that in 1998?
Provide a succinct answer. 0.94. What is the ratio of the Value added (constant Local Currency Unit) of Guinea in 1995 to that in 1999?
Your answer should be compact. 0.81. What is the ratio of the Value added (constant Local Currency Unit) in Indonesia in 1995 to that in 1999?
Provide a succinct answer. 0.95. What is the ratio of the Value added (constant Local Currency Unit) of Italy in 1995 to that in 1999?
Your response must be concise. 0.89. What is the ratio of the Value added (constant Local Currency Unit) of Guinea in 1995 to that in 2000?
Your response must be concise. 0.78. What is the ratio of the Value added (constant Local Currency Unit) in Indonesia in 1995 to that in 2000?
Offer a very short reply. 0.93. What is the ratio of the Value added (constant Local Currency Unit) of Italy in 1995 to that in 2000?
Give a very brief answer. 0.9. What is the ratio of the Value added (constant Local Currency Unit) in Guinea in 1996 to that in 1997?
Make the answer very short. 0.94. What is the ratio of the Value added (constant Local Currency Unit) in Italy in 1996 to that in 1997?
Provide a short and direct response. 0.98. What is the ratio of the Value added (constant Local Currency Unit) in Guinea in 1996 to that in 1998?
Make the answer very short. 0.9. What is the ratio of the Value added (constant Local Currency Unit) in Indonesia in 1996 to that in 1998?
Offer a very short reply. 1. What is the ratio of the Value added (constant Local Currency Unit) in Italy in 1996 to that in 1998?
Offer a terse response. 0.95. What is the ratio of the Value added (constant Local Currency Unit) of Guinea in 1996 to that in 1999?
Give a very brief answer. 0.84. What is the ratio of the Value added (constant Local Currency Unit) of Indonesia in 1996 to that in 1999?
Give a very brief answer. 0.98. What is the ratio of the Value added (constant Local Currency Unit) of Italy in 1996 to that in 1999?
Provide a succinct answer. 0.9. What is the ratio of the Value added (constant Local Currency Unit) in Guinea in 1996 to that in 2000?
Provide a succinct answer. 0.82. What is the ratio of the Value added (constant Local Currency Unit) of Indonesia in 1996 to that in 2000?
Offer a terse response. 0.96. What is the ratio of the Value added (constant Local Currency Unit) of Italy in 1996 to that in 2000?
Offer a terse response. 0.91. What is the ratio of the Value added (constant Local Currency Unit) in Guinea in 1997 to that in 1998?
Give a very brief answer. 0.96. What is the ratio of the Value added (constant Local Currency Unit) of Indonesia in 1997 to that in 1998?
Keep it short and to the point. 1.01. What is the ratio of the Value added (constant Local Currency Unit) of Italy in 1997 to that in 1998?
Offer a very short reply. 0.97. What is the ratio of the Value added (constant Local Currency Unit) in Guinea in 1997 to that in 1999?
Your answer should be very brief. 0.9. What is the ratio of the Value added (constant Local Currency Unit) of Indonesia in 1997 to that in 1999?
Give a very brief answer. 0.99. What is the ratio of the Value added (constant Local Currency Unit) in Italy in 1997 to that in 1999?
Provide a succinct answer. 0.92. What is the ratio of the Value added (constant Local Currency Unit) of Guinea in 1997 to that in 2000?
Offer a terse response. 0.87. What is the ratio of the Value added (constant Local Currency Unit) of Indonesia in 1997 to that in 2000?
Give a very brief answer. 0.97. What is the ratio of the Value added (constant Local Currency Unit) in Italy in 1997 to that in 2000?
Provide a short and direct response. 0.93. What is the ratio of the Value added (constant Local Currency Unit) in Guinea in 1998 to that in 1999?
Make the answer very short. 0.94. What is the ratio of the Value added (constant Local Currency Unit) of Indonesia in 1998 to that in 1999?
Ensure brevity in your answer.  0.98. What is the ratio of the Value added (constant Local Currency Unit) in Italy in 1998 to that in 1999?
Make the answer very short. 0.95. What is the ratio of the Value added (constant Local Currency Unit) in Guinea in 1998 to that in 2000?
Offer a terse response. 0.91. What is the ratio of the Value added (constant Local Currency Unit) of Indonesia in 1998 to that in 2000?
Your answer should be compact. 0.96. What is the ratio of the Value added (constant Local Currency Unit) of Guinea in 1999 to that in 2000?
Provide a short and direct response. 0.97. What is the ratio of the Value added (constant Local Currency Unit) of Indonesia in 1999 to that in 2000?
Your answer should be compact. 0.98. What is the ratio of the Value added (constant Local Currency Unit) in Italy in 1999 to that in 2000?
Provide a succinct answer. 1.01. What is the difference between the highest and the second highest Value added (constant Local Currency Unit) of Guinea?
Your answer should be compact. 3.56e+1. What is the difference between the highest and the second highest Value added (constant Local Currency Unit) in Indonesia?
Your answer should be compact. 1.26e+13. What is the difference between the highest and the second highest Value added (constant Local Currency Unit) of Italy?
Your answer should be very brief. 4.00e+08. What is the difference between the highest and the lowest Value added (constant Local Currency Unit) in Guinea?
Provide a short and direct response. 3.37e+11. What is the difference between the highest and the lowest Value added (constant Local Currency Unit) in Indonesia?
Provide a succinct answer. 7.44e+13. What is the difference between the highest and the lowest Value added (constant Local Currency Unit) in Italy?
Provide a succinct answer. 4.15e+09. 